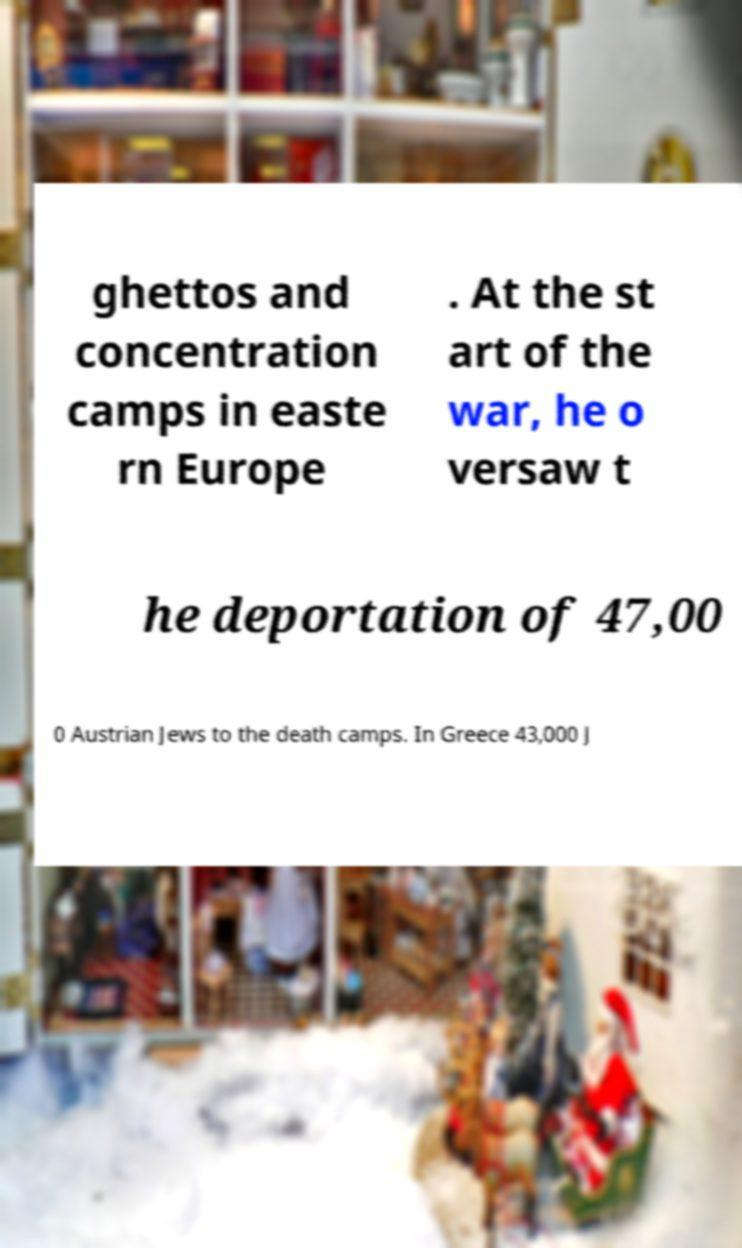Could you assist in decoding the text presented in this image and type it out clearly? ghettos and concentration camps in easte rn Europe . At the st art of the war, he o versaw t he deportation of 47,00 0 Austrian Jews to the death camps. In Greece 43,000 J 